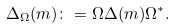Convert formula to latex. <formula><loc_0><loc_0><loc_500><loc_500>\Delta _ { \Omega } ( m ) \colon = \Omega \Delta ( m ) \Omega ^ { * } .</formula> 